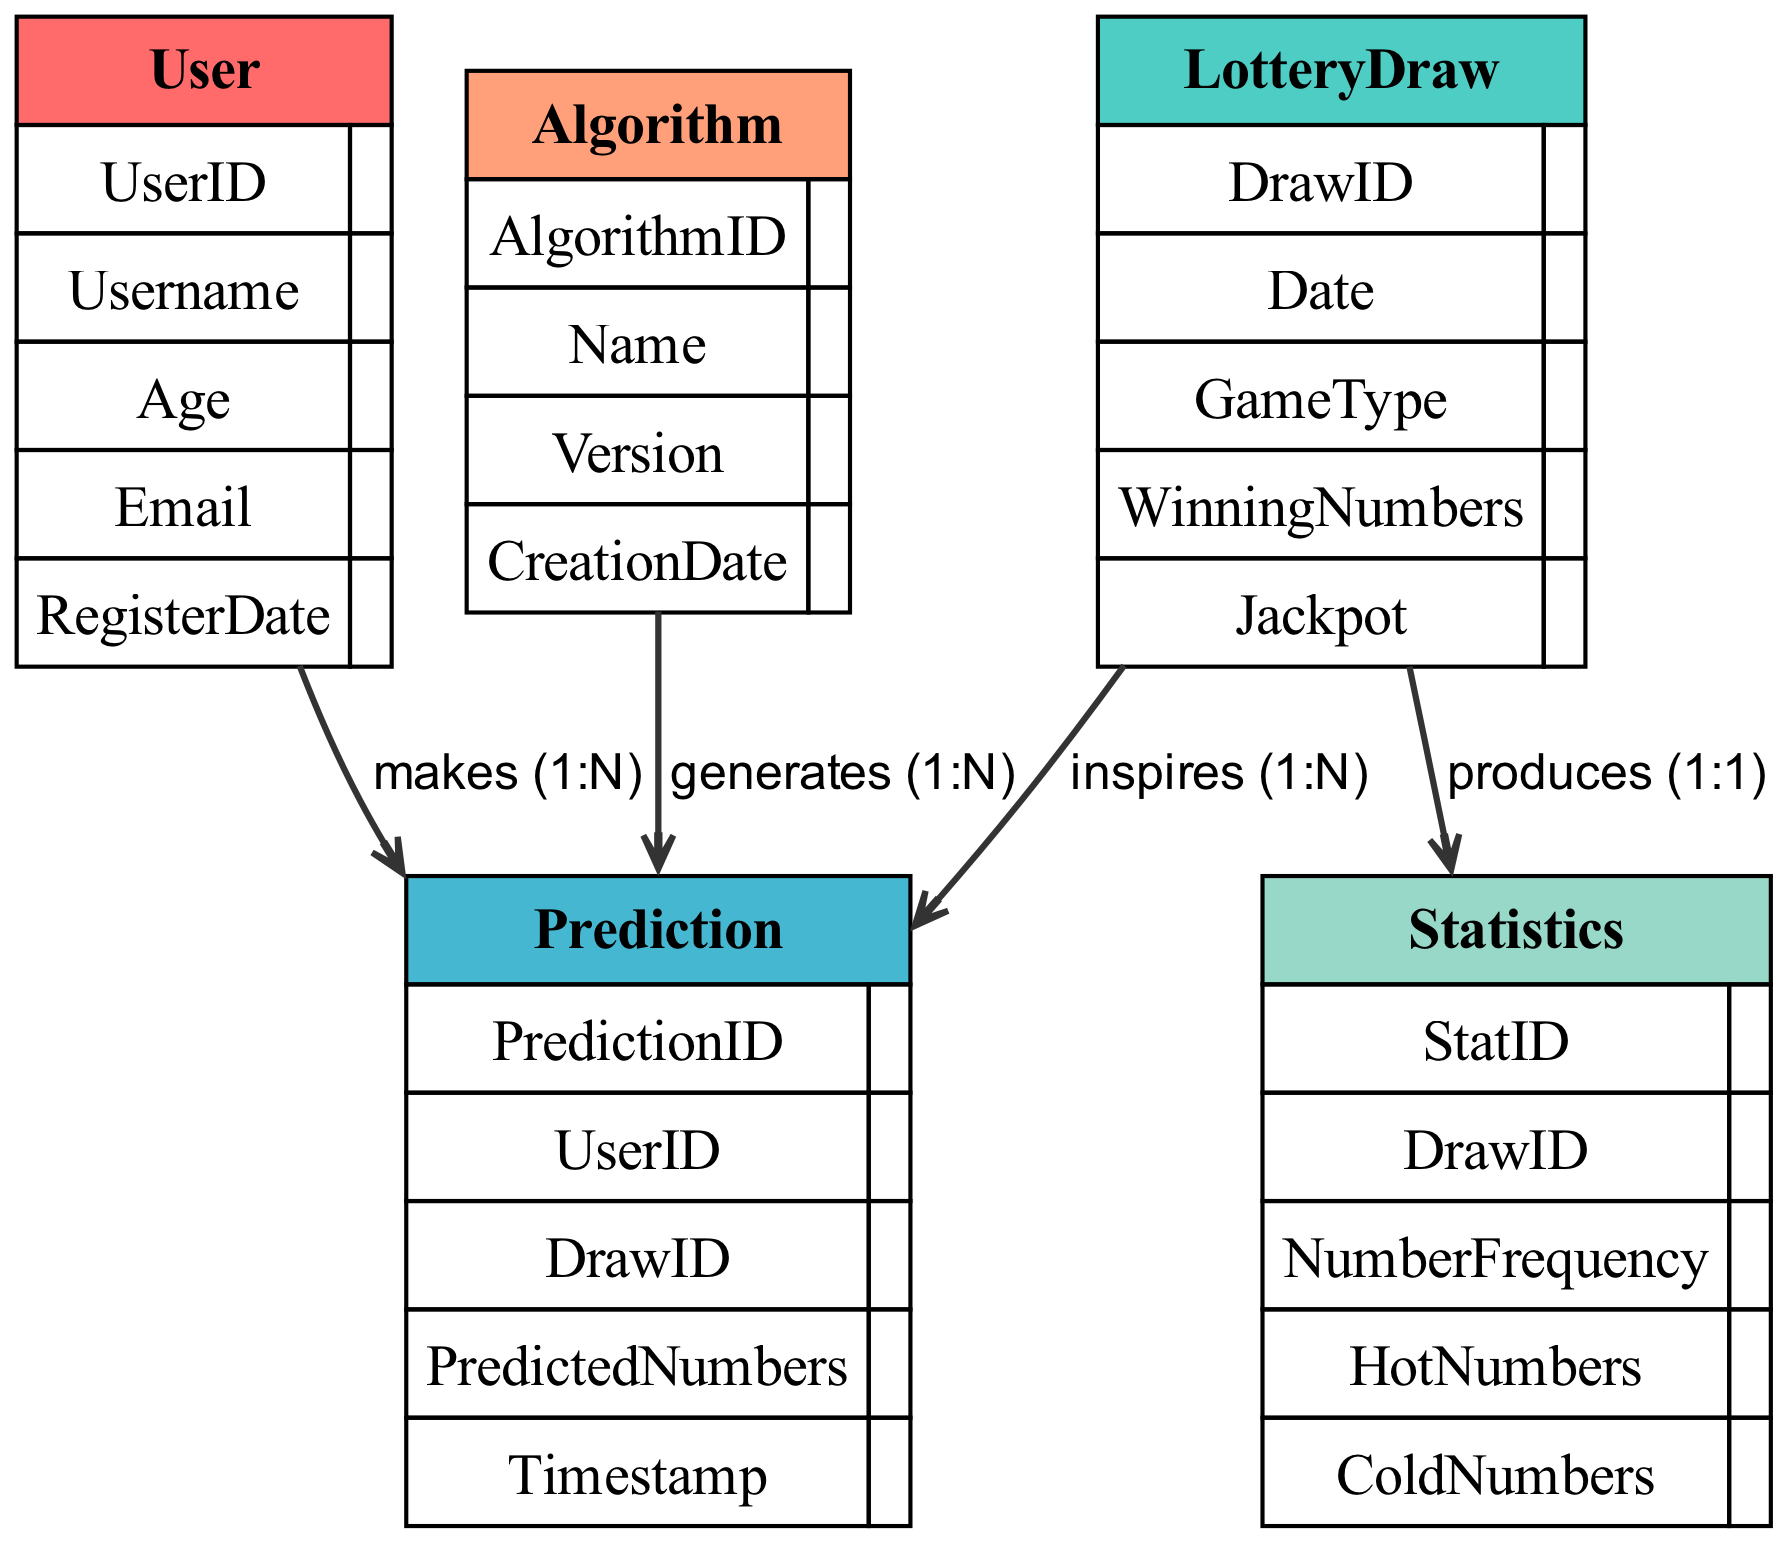What is the primary relationship type between User and Prediction? In the diagram, the relationship is labeled as "makes" which indicates that a User has a direct involvement in creating or generating a Prediction. This means for each User, there can be multiple associated Predictions.
Answer: makes How many entities are there in the diagram? The diagram includes five distinct entities: User, LotteryDraw, Prediction, Algorithm, and Statistics. Counting each of them provides the total.
Answer: 5 What attribute identifies a LotteryDraw? The unique identifier attribute for a LotteryDraw is "DrawID", which denotes each LotteryDraw instance to be distinct from others.
Answer: DrawID What is the cardinality of the relationship between LotteryDraw and Statistics? The relationship between LotteryDraw and Statistics is indicated with a cardinality of "1:1", meaning each LotteryDraw corresponds directly to one Statistics record.
Answer: 1:1 Which entity has the relationship labeled "inspires"? The "inspires" relationship originates from LotteryDraw directed to Prediction, implying that the occurrences or outcomes of LotteryDraw influence the Predictions made by Users.
Answer: LotteryDraw How many predictions can a User make according to the diagram? The cardinality shown in the relationship indicates that a User can make multiple Predictions, represented by "1:N", which specifies that one User can be associated with numerous Predictions.
Answer: N What entity produces Statistics? The diagram shows that the LotteryDraw entity produces Statistics, indicating a direct relationship where each LotteryDraw results in the generation of corresponding statistical data.
Answer: LotteryDraw Which attribute stores the predicted numbers in Prediction? The "PredictedNumbers" attribute in the Prediction entity is designated for storing the numbers that the user predicts for a specific lottery draw.
Answer: PredictedNumbers How many unique Algorithms can be associated with Predictions? The cardinality in the relationship between Algorithm and Prediction is "1:N", meaning one unique Algorithm can generate multiple Predictions, allowing for various outcomes from a single algorithm version.
Answer: N 